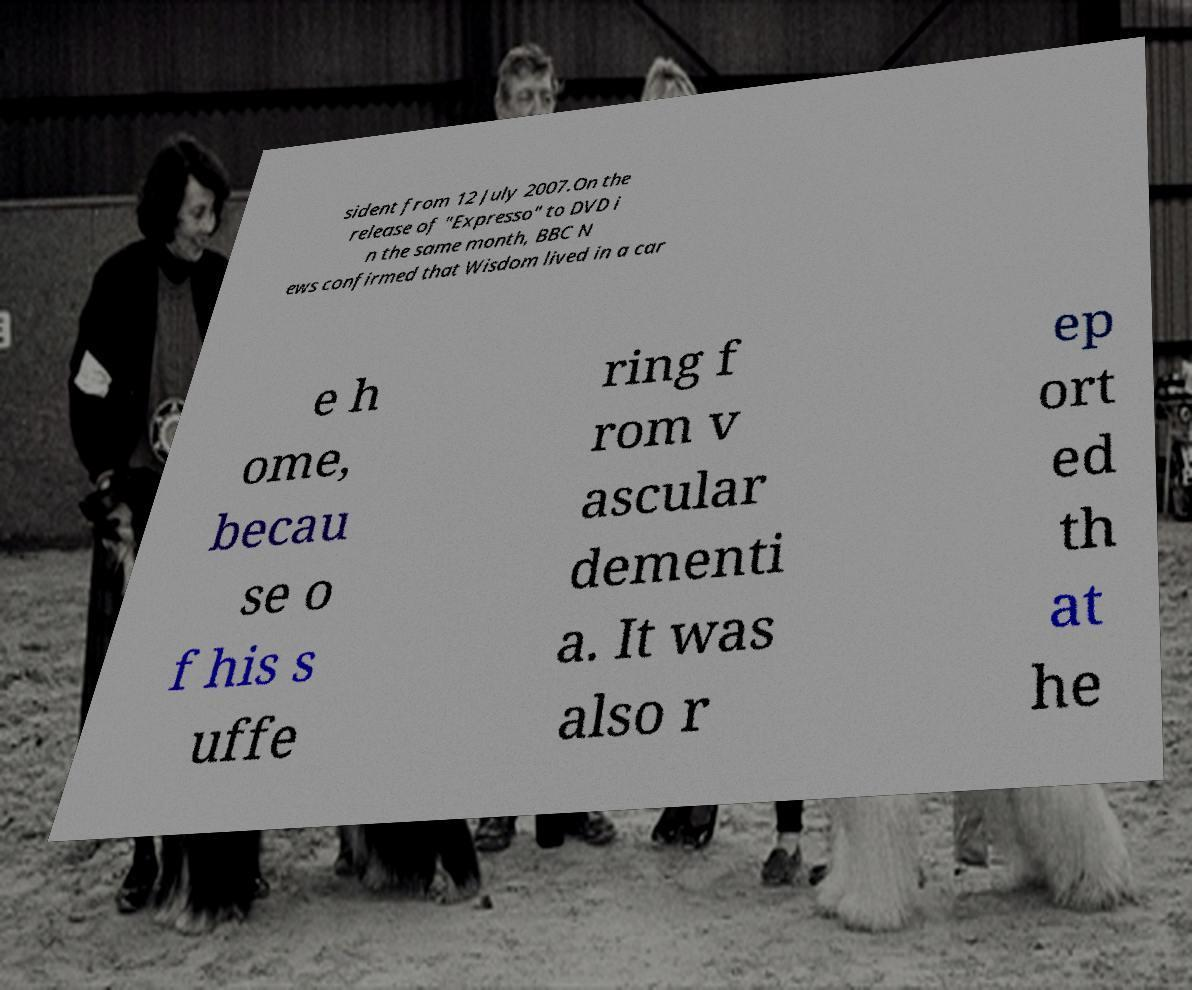Could you assist in decoding the text presented in this image and type it out clearly? sident from 12 July 2007.On the release of "Expresso" to DVD i n the same month, BBC N ews confirmed that Wisdom lived in a car e h ome, becau se o f his s uffe ring f rom v ascular dementi a. It was also r ep ort ed th at he 